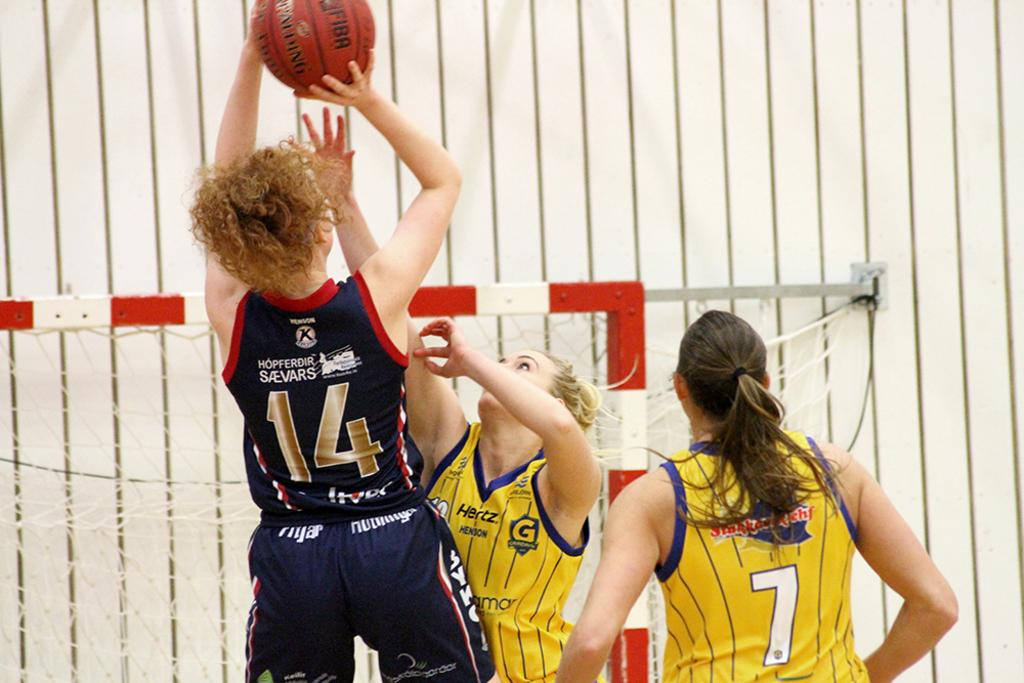<image>
Write a terse but informative summary of the picture. Basketball player wearing number 14 about to shoot a shot. 